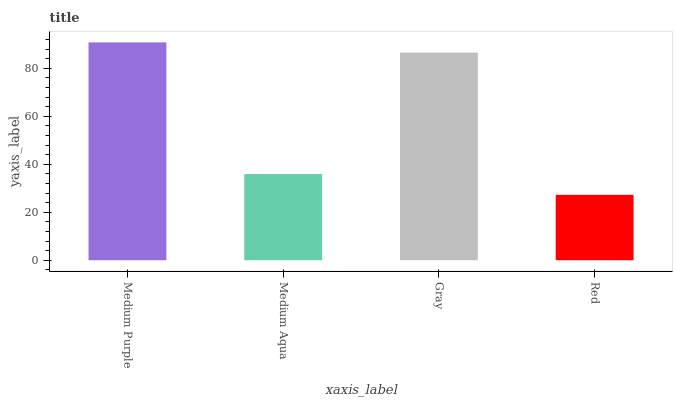Is Red the minimum?
Answer yes or no. Yes. Is Medium Purple the maximum?
Answer yes or no. Yes. Is Medium Aqua the minimum?
Answer yes or no. No. Is Medium Aqua the maximum?
Answer yes or no. No. Is Medium Purple greater than Medium Aqua?
Answer yes or no. Yes. Is Medium Aqua less than Medium Purple?
Answer yes or no. Yes. Is Medium Aqua greater than Medium Purple?
Answer yes or no. No. Is Medium Purple less than Medium Aqua?
Answer yes or no. No. Is Gray the high median?
Answer yes or no. Yes. Is Medium Aqua the low median?
Answer yes or no. Yes. Is Red the high median?
Answer yes or no. No. Is Medium Purple the low median?
Answer yes or no. No. 